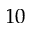Convert formula to latex. <formula><loc_0><loc_0><loc_500><loc_500>1 0</formula> 